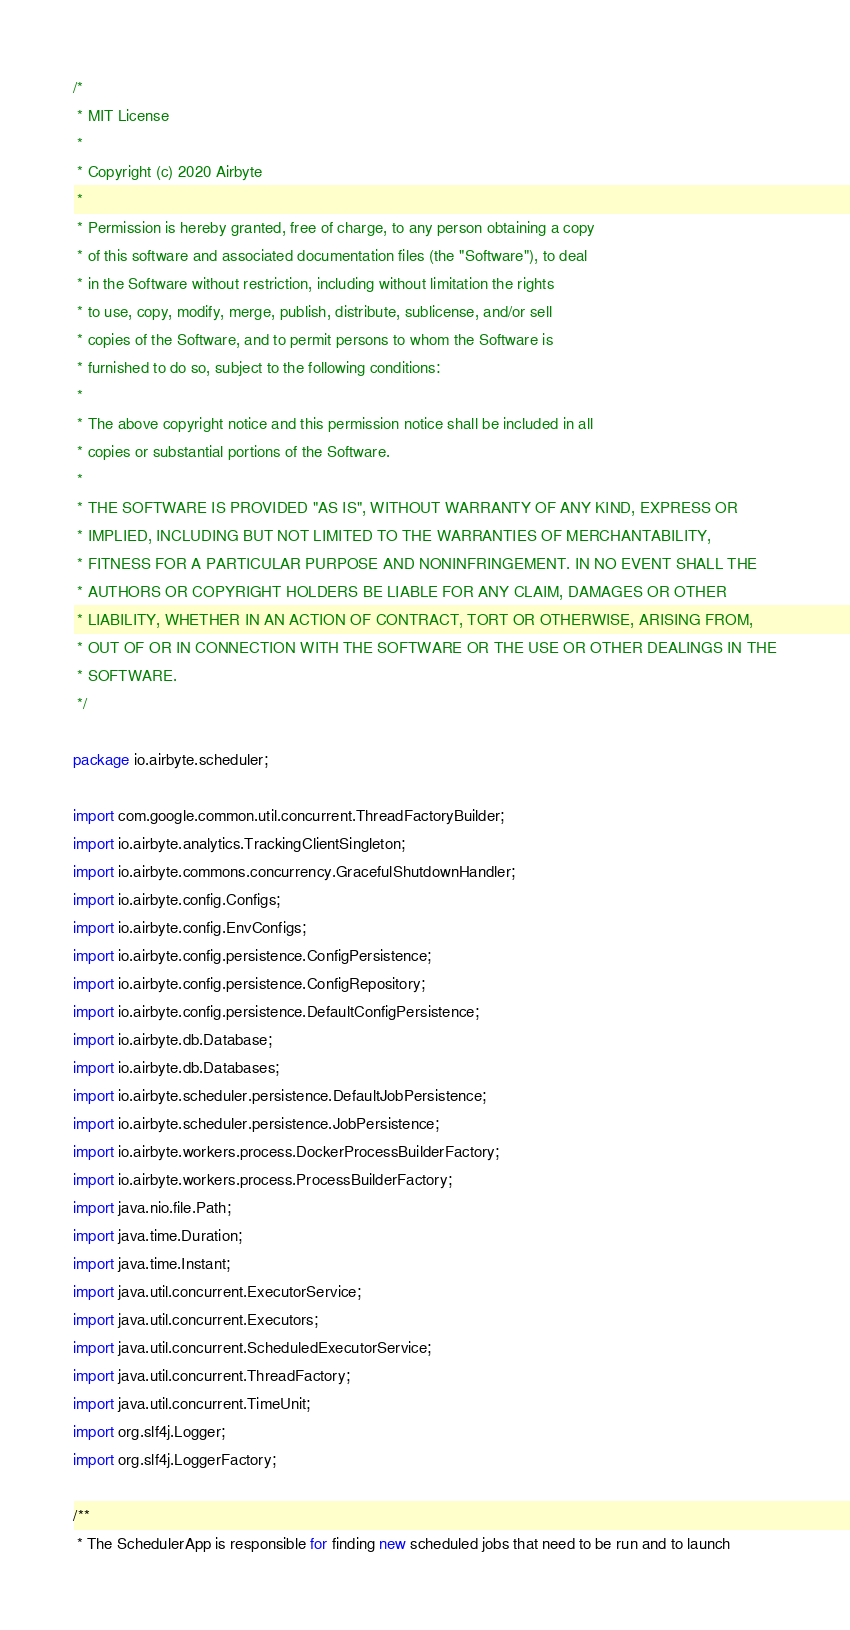Convert code to text. <code><loc_0><loc_0><loc_500><loc_500><_Java_>/*
 * MIT License
 *
 * Copyright (c) 2020 Airbyte
 *
 * Permission is hereby granted, free of charge, to any person obtaining a copy
 * of this software and associated documentation files (the "Software"), to deal
 * in the Software without restriction, including without limitation the rights
 * to use, copy, modify, merge, publish, distribute, sublicense, and/or sell
 * copies of the Software, and to permit persons to whom the Software is
 * furnished to do so, subject to the following conditions:
 *
 * The above copyright notice and this permission notice shall be included in all
 * copies or substantial portions of the Software.
 *
 * THE SOFTWARE IS PROVIDED "AS IS", WITHOUT WARRANTY OF ANY KIND, EXPRESS OR
 * IMPLIED, INCLUDING BUT NOT LIMITED TO THE WARRANTIES OF MERCHANTABILITY,
 * FITNESS FOR A PARTICULAR PURPOSE AND NONINFRINGEMENT. IN NO EVENT SHALL THE
 * AUTHORS OR COPYRIGHT HOLDERS BE LIABLE FOR ANY CLAIM, DAMAGES OR OTHER
 * LIABILITY, WHETHER IN AN ACTION OF CONTRACT, TORT OR OTHERWISE, ARISING FROM,
 * OUT OF OR IN CONNECTION WITH THE SOFTWARE OR THE USE OR OTHER DEALINGS IN THE
 * SOFTWARE.
 */

package io.airbyte.scheduler;

import com.google.common.util.concurrent.ThreadFactoryBuilder;
import io.airbyte.analytics.TrackingClientSingleton;
import io.airbyte.commons.concurrency.GracefulShutdownHandler;
import io.airbyte.config.Configs;
import io.airbyte.config.EnvConfigs;
import io.airbyte.config.persistence.ConfigPersistence;
import io.airbyte.config.persistence.ConfigRepository;
import io.airbyte.config.persistence.DefaultConfigPersistence;
import io.airbyte.db.Database;
import io.airbyte.db.Databases;
import io.airbyte.scheduler.persistence.DefaultJobPersistence;
import io.airbyte.scheduler.persistence.JobPersistence;
import io.airbyte.workers.process.DockerProcessBuilderFactory;
import io.airbyte.workers.process.ProcessBuilderFactory;
import java.nio.file.Path;
import java.time.Duration;
import java.time.Instant;
import java.util.concurrent.ExecutorService;
import java.util.concurrent.Executors;
import java.util.concurrent.ScheduledExecutorService;
import java.util.concurrent.ThreadFactory;
import java.util.concurrent.TimeUnit;
import org.slf4j.Logger;
import org.slf4j.LoggerFactory;

/**
 * The SchedulerApp is responsible for finding new scheduled jobs that need to be run and to launch</code> 